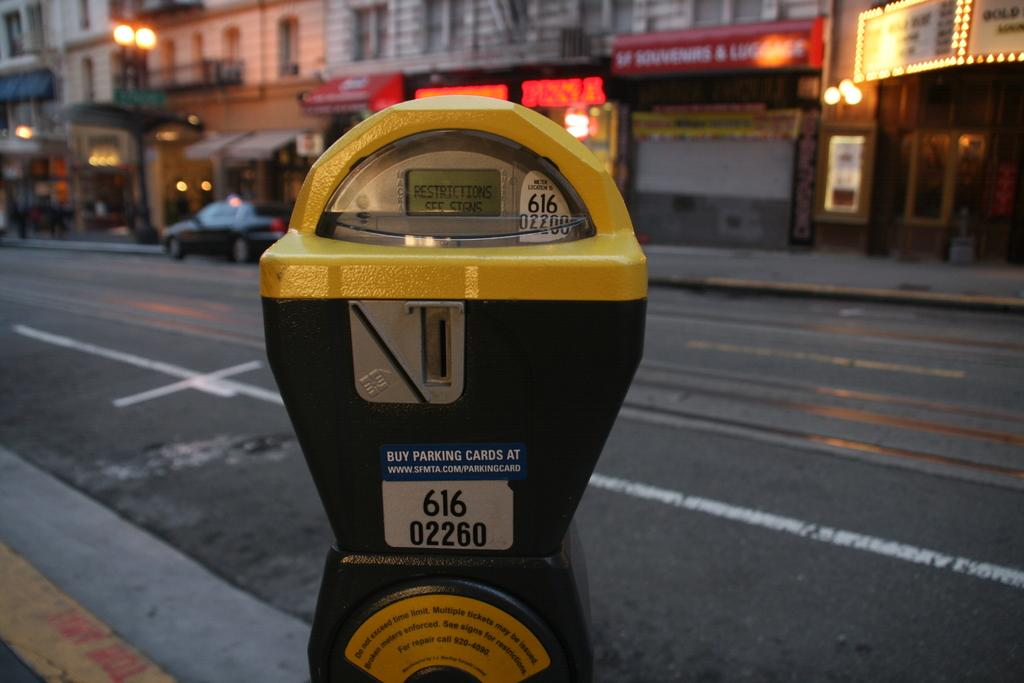Provide a one-sentence caption for the provided image. A parking meter on a city street registered under the number 616 02260. 